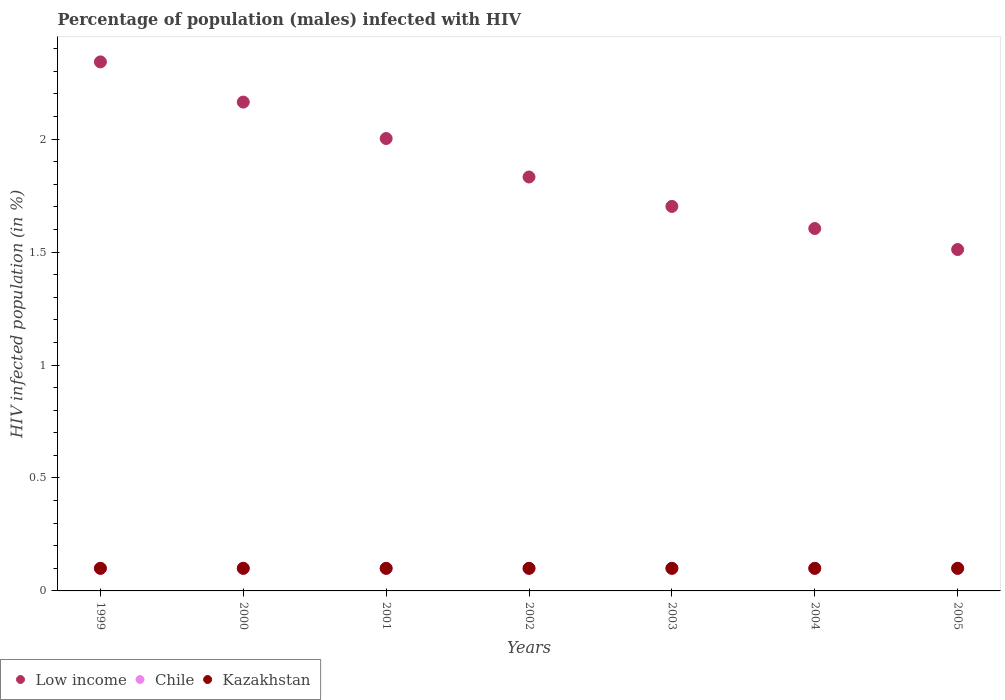How many different coloured dotlines are there?
Keep it short and to the point. 3. Is the number of dotlines equal to the number of legend labels?
Your answer should be very brief. Yes. Across all years, what is the maximum percentage of HIV infected male population in Chile?
Your answer should be compact. 0.1. Across all years, what is the minimum percentage of HIV infected male population in Low income?
Provide a short and direct response. 1.51. What is the total percentage of HIV infected male population in Chile in the graph?
Keep it short and to the point. 0.7. What is the difference between the percentage of HIV infected male population in Kazakhstan in 1999 and that in 2004?
Keep it short and to the point. 0. What is the difference between the percentage of HIV infected male population in Low income in 2005 and the percentage of HIV infected male population in Chile in 2000?
Keep it short and to the point. 1.41. What is the average percentage of HIV infected male population in Low income per year?
Offer a very short reply. 1.88. In the year 2003, what is the difference between the percentage of HIV infected male population in Chile and percentage of HIV infected male population in Kazakhstan?
Ensure brevity in your answer.  0. In how many years, is the percentage of HIV infected male population in Low income greater than 2.2 %?
Give a very brief answer. 1. What is the difference between the highest and the lowest percentage of HIV infected male population in Low income?
Provide a short and direct response. 0.83. In how many years, is the percentage of HIV infected male population in Kazakhstan greater than the average percentage of HIV infected male population in Kazakhstan taken over all years?
Make the answer very short. 7. Is the percentage of HIV infected male population in Chile strictly greater than the percentage of HIV infected male population in Low income over the years?
Offer a very short reply. No. How many dotlines are there?
Make the answer very short. 3. What is the difference between two consecutive major ticks on the Y-axis?
Ensure brevity in your answer.  0.5. Are the values on the major ticks of Y-axis written in scientific E-notation?
Offer a terse response. No. Does the graph contain any zero values?
Ensure brevity in your answer.  No. Does the graph contain grids?
Provide a succinct answer. No. Where does the legend appear in the graph?
Keep it short and to the point. Bottom left. What is the title of the graph?
Ensure brevity in your answer.  Percentage of population (males) infected with HIV. What is the label or title of the Y-axis?
Provide a short and direct response. HIV infected population (in %). What is the HIV infected population (in %) of Low income in 1999?
Offer a very short reply. 2.34. What is the HIV infected population (in %) in Low income in 2000?
Make the answer very short. 2.16. What is the HIV infected population (in %) in Chile in 2000?
Provide a succinct answer. 0.1. What is the HIV infected population (in %) of Low income in 2001?
Keep it short and to the point. 2. What is the HIV infected population (in %) of Low income in 2002?
Ensure brevity in your answer.  1.83. What is the HIV infected population (in %) in Low income in 2003?
Offer a terse response. 1.7. What is the HIV infected population (in %) of Chile in 2003?
Give a very brief answer. 0.1. What is the HIV infected population (in %) in Low income in 2004?
Your answer should be compact. 1.6. What is the HIV infected population (in %) of Kazakhstan in 2004?
Offer a very short reply. 0.1. What is the HIV infected population (in %) of Low income in 2005?
Keep it short and to the point. 1.51. What is the HIV infected population (in %) of Kazakhstan in 2005?
Give a very brief answer. 0.1. Across all years, what is the maximum HIV infected population (in %) in Low income?
Ensure brevity in your answer.  2.34. Across all years, what is the maximum HIV infected population (in %) in Chile?
Give a very brief answer. 0.1. Across all years, what is the minimum HIV infected population (in %) in Low income?
Provide a succinct answer. 1.51. Across all years, what is the minimum HIV infected population (in %) in Chile?
Offer a very short reply. 0.1. What is the total HIV infected population (in %) of Low income in the graph?
Provide a short and direct response. 13.16. What is the total HIV infected population (in %) in Kazakhstan in the graph?
Your answer should be very brief. 0.7. What is the difference between the HIV infected population (in %) of Low income in 1999 and that in 2000?
Your response must be concise. 0.18. What is the difference between the HIV infected population (in %) of Kazakhstan in 1999 and that in 2000?
Make the answer very short. 0. What is the difference between the HIV infected population (in %) in Low income in 1999 and that in 2001?
Offer a terse response. 0.34. What is the difference between the HIV infected population (in %) of Chile in 1999 and that in 2001?
Give a very brief answer. 0. What is the difference between the HIV infected population (in %) in Kazakhstan in 1999 and that in 2001?
Offer a very short reply. 0. What is the difference between the HIV infected population (in %) in Low income in 1999 and that in 2002?
Provide a short and direct response. 0.51. What is the difference between the HIV infected population (in %) in Low income in 1999 and that in 2003?
Provide a succinct answer. 0.64. What is the difference between the HIV infected population (in %) in Kazakhstan in 1999 and that in 2003?
Offer a very short reply. 0. What is the difference between the HIV infected population (in %) of Low income in 1999 and that in 2004?
Offer a very short reply. 0.74. What is the difference between the HIV infected population (in %) of Chile in 1999 and that in 2004?
Provide a succinct answer. 0. What is the difference between the HIV infected population (in %) in Kazakhstan in 1999 and that in 2004?
Ensure brevity in your answer.  0. What is the difference between the HIV infected population (in %) of Low income in 1999 and that in 2005?
Give a very brief answer. 0.83. What is the difference between the HIV infected population (in %) in Chile in 1999 and that in 2005?
Your answer should be very brief. 0. What is the difference between the HIV infected population (in %) of Kazakhstan in 1999 and that in 2005?
Keep it short and to the point. 0. What is the difference between the HIV infected population (in %) in Low income in 2000 and that in 2001?
Offer a terse response. 0.16. What is the difference between the HIV infected population (in %) in Chile in 2000 and that in 2001?
Make the answer very short. 0. What is the difference between the HIV infected population (in %) in Low income in 2000 and that in 2002?
Provide a short and direct response. 0.33. What is the difference between the HIV infected population (in %) in Chile in 2000 and that in 2002?
Provide a succinct answer. 0. What is the difference between the HIV infected population (in %) of Low income in 2000 and that in 2003?
Provide a short and direct response. 0.46. What is the difference between the HIV infected population (in %) of Chile in 2000 and that in 2003?
Offer a terse response. 0. What is the difference between the HIV infected population (in %) of Kazakhstan in 2000 and that in 2003?
Provide a short and direct response. 0. What is the difference between the HIV infected population (in %) of Low income in 2000 and that in 2004?
Ensure brevity in your answer.  0.56. What is the difference between the HIV infected population (in %) of Chile in 2000 and that in 2004?
Make the answer very short. 0. What is the difference between the HIV infected population (in %) of Kazakhstan in 2000 and that in 2004?
Offer a terse response. 0. What is the difference between the HIV infected population (in %) in Low income in 2000 and that in 2005?
Your response must be concise. 0.65. What is the difference between the HIV infected population (in %) in Kazakhstan in 2000 and that in 2005?
Your answer should be compact. 0. What is the difference between the HIV infected population (in %) of Low income in 2001 and that in 2002?
Make the answer very short. 0.17. What is the difference between the HIV infected population (in %) of Chile in 2001 and that in 2002?
Provide a succinct answer. 0. What is the difference between the HIV infected population (in %) of Kazakhstan in 2001 and that in 2002?
Provide a short and direct response. 0. What is the difference between the HIV infected population (in %) of Low income in 2001 and that in 2003?
Offer a terse response. 0.3. What is the difference between the HIV infected population (in %) in Kazakhstan in 2001 and that in 2003?
Offer a very short reply. 0. What is the difference between the HIV infected population (in %) in Low income in 2001 and that in 2004?
Give a very brief answer. 0.4. What is the difference between the HIV infected population (in %) of Chile in 2001 and that in 2004?
Provide a succinct answer. 0. What is the difference between the HIV infected population (in %) in Kazakhstan in 2001 and that in 2004?
Your answer should be very brief. 0. What is the difference between the HIV infected population (in %) in Low income in 2001 and that in 2005?
Give a very brief answer. 0.49. What is the difference between the HIV infected population (in %) in Low income in 2002 and that in 2003?
Make the answer very short. 0.13. What is the difference between the HIV infected population (in %) in Kazakhstan in 2002 and that in 2003?
Give a very brief answer. 0. What is the difference between the HIV infected population (in %) of Low income in 2002 and that in 2004?
Keep it short and to the point. 0.23. What is the difference between the HIV infected population (in %) of Chile in 2002 and that in 2004?
Your answer should be very brief. 0. What is the difference between the HIV infected population (in %) in Low income in 2002 and that in 2005?
Provide a short and direct response. 0.32. What is the difference between the HIV infected population (in %) in Chile in 2002 and that in 2005?
Your response must be concise. 0. What is the difference between the HIV infected population (in %) in Kazakhstan in 2002 and that in 2005?
Keep it short and to the point. 0. What is the difference between the HIV infected population (in %) in Low income in 2003 and that in 2004?
Give a very brief answer. 0.1. What is the difference between the HIV infected population (in %) of Low income in 2003 and that in 2005?
Your response must be concise. 0.19. What is the difference between the HIV infected population (in %) in Chile in 2003 and that in 2005?
Make the answer very short. 0. What is the difference between the HIV infected population (in %) in Low income in 2004 and that in 2005?
Give a very brief answer. 0.09. What is the difference between the HIV infected population (in %) in Kazakhstan in 2004 and that in 2005?
Ensure brevity in your answer.  0. What is the difference between the HIV infected population (in %) in Low income in 1999 and the HIV infected population (in %) in Chile in 2000?
Your answer should be very brief. 2.24. What is the difference between the HIV infected population (in %) in Low income in 1999 and the HIV infected population (in %) in Kazakhstan in 2000?
Give a very brief answer. 2.24. What is the difference between the HIV infected population (in %) in Low income in 1999 and the HIV infected population (in %) in Chile in 2001?
Your answer should be very brief. 2.24. What is the difference between the HIV infected population (in %) of Low income in 1999 and the HIV infected population (in %) of Kazakhstan in 2001?
Your response must be concise. 2.24. What is the difference between the HIV infected population (in %) in Low income in 1999 and the HIV infected population (in %) in Chile in 2002?
Keep it short and to the point. 2.24. What is the difference between the HIV infected population (in %) of Low income in 1999 and the HIV infected population (in %) of Kazakhstan in 2002?
Give a very brief answer. 2.24. What is the difference between the HIV infected population (in %) of Low income in 1999 and the HIV infected population (in %) of Chile in 2003?
Your answer should be compact. 2.24. What is the difference between the HIV infected population (in %) in Low income in 1999 and the HIV infected population (in %) in Kazakhstan in 2003?
Offer a terse response. 2.24. What is the difference between the HIV infected population (in %) in Chile in 1999 and the HIV infected population (in %) in Kazakhstan in 2003?
Your answer should be very brief. 0. What is the difference between the HIV infected population (in %) in Low income in 1999 and the HIV infected population (in %) in Chile in 2004?
Offer a very short reply. 2.24. What is the difference between the HIV infected population (in %) in Low income in 1999 and the HIV infected population (in %) in Kazakhstan in 2004?
Offer a very short reply. 2.24. What is the difference between the HIV infected population (in %) of Low income in 1999 and the HIV infected population (in %) of Chile in 2005?
Ensure brevity in your answer.  2.24. What is the difference between the HIV infected population (in %) in Low income in 1999 and the HIV infected population (in %) in Kazakhstan in 2005?
Keep it short and to the point. 2.24. What is the difference between the HIV infected population (in %) of Chile in 1999 and the HIV infected population (in %) of Kazakhstan in 2005?
Keep it short and to the point. 0. What is the difference between the HIV infected population (in %) in Low income in 2000 and the HIV infected population (in %) in Chile in 2001?
Your response must be concise. 2.06. What is the difference between the HIV infected population (in %) in Low income in 2000 and the HIV infected population (in %) in Kazakhstan in 2001?
Ensure brevity in your answer.  2.06. What is the difference between the HIV infected population (in %) in Low income in 2000 and the HIV infected population (in %) in Chile in 2002?
Give a very brief answer. 2.06. What is the difference between the HIV infected population (in %) of Low income in 2000 and the HIV infected population (in %) of Kazakhstan in 2002?
Keep it short and to the point. 2.06. What is the difference between the HIV infected population (in %) in Low income in 2000 and the HIV infected population (in %) in Chile in 2003?
Your answer should be very brief. 2.06. What is the difference between the HIV infected population (in %) of Low income in 2000 and the HIV infected population (in %) of Kazakhstan in 2003?
Provide a succinct answer. 2.06. What is the difference between the HIV infected population (in %) in Low income in 2000 and the HIV infected population (in %) in Chile in 2004?
Make the answer very short. 2.06. What is the difference between the HIV infected population (in %) in Low income in 2000 and the HIV infected population (in %) in Kazakhstan in 2004?
Your answer should be compact. 2.06. What is the difference between the HIV infected population (in %) in Low income in 2000 and the HIV infected population (in %) in Chile in 2005?
Your answer should be compact. 2.06. What is the difference between the HIV infected population (in %) of Low income in 2000 and the HIV infected population (in %) of Kazakhstan in 2005?
Give a very brief answer. 2.06. What is the difference between the HIV infected population (in %) of Low income in 2001 and the HIV infected population (in %) of Chile in 2002?
Provide a short and direct response. 1.9. What is the difference between the HIV infected population (in %) of Low income in 2001 and the HIV infected population (in %) of Kazakhstan in 2002?
Make the answer very short. 1.9. What is the difference between the HIV infected population (in %) of Chile in 2001 and the HIV infected population (in %) of Kazakhstan in 2002?
Make the answer very short. 0. What is the difference between the HIV infected population (in %) of Low income in 2001 and the HIV infected population (in %) of Chile in 2003?
Give a very brief answer. 1.9. What is the difference between the HIV infected population (in %) of Low income in 2001 and the HIV infected population (in %) of Kazakhstan in 2003?
Your answer should be very brief. 1.9. What is the difference between the HIV infected population (in %) of Chile in 2001 and the HIV infected population (in %) of Kazakhstan in 2003?
Your answer should be compact. 0. What is the difference between the HIV infected population (in %) of Low income in 2001 and the HIV infected population (in %) of Chile in 2004?
Keep it short and to the point. 1.9. What is the difference between the HIV infected population (in %) in Low income in 2001 and the HIV infected population (in %) in Kazakhstan in 2004?
Your response must be concise. 1.9. What is the difference between the HIV infected population (in %) in Chile in 2001 and the HIV infected population (in %) in Kazakhstan in 2004?
Provide a short and direct response. 0. What is the difference between the HIV infected population (in %) in Low income in 2001 and the HIV infected population (in %) in Chile in 2005?
Provide a succinct answer. 1.9. What is the difference between the HIV infected population (in %) of Low income in 2001 and the HIV infected population (in %) of Kazakhstan in 2005?
Provide a short and direct response. 1.9. What is the difference between the HIV infected population (in %) of Chile in 2001 and the HIV infected population (in %) of Kazakhstan in 2005?
Make the answer very short. 0. What is the difference between the HIV infected population (in %) of Low income in 2002 and the HIV infected population (in %) of Chile in 2003?
Give a very brief answer. 1.73. What is the difference between the HIV infected population (in %) of Low income in 2002 and the HIV infected population (in %) of Kazakhstan in 2003?
Provide a short and direct response. 1.73. What is the difference between the HIV infected population (in %) of Chile in 2002 and the HIV infected population (in %) of Kazakhstan in 2003?
Make the answer very short. 0. What is the difference between the HIV infected population (in %) in Low income in 2002 and the HIV infected population (in %) in Chile in 2004?
Offer a terse response. 1.73. What is the difference between the HIV infected population (in %) in Low income in 2002 and the HIV infected population (in %) in Kazakhstan in 2004?
Provide a short and direct response. 1.73. What is the difference between the HIV infected population (in %) of Low income in 2002 and the HIV infected population (in %) of Chile in 2005?
Provide a succinct answer. 1.73. What is the difference between the HIV infected population (in %) of Low income in 2002 and the HIV infected population (in %) of Kazakhstan in 2005?
Provide a short and direct response. 1.73. What is the difference between the HIV infected population (in %) of Chile in 2002 and the HIV infected population (in %) of Kazakhstan in 2005?
Your response must be concise. 0. What is the difference between the HIV infected population (in %) in Low income in 2003 and the HIV infected population (in %) in Chile in 2004?
Make the answer very short. 1.6. What is the difference between the HIV infected population (in %) of Low income in 2003 and the HIV infected population (in %) of Kazakhstan in 2004?
Your answer should be compact. 1.6. What is the difference between the HIV infected population (in %) in Low income in 2003 and the HIV infected population (in %) in Chile in 2005?
Your answer should be very brief. 1.6. What is the difference between the HIV infected population (in %) in Low income in 2003 and the HIV infected population (in %) in Kazakhstan in 2005?
Provide a succinct answer. 1.6. What is the difference between the HIV infected population (in %) of Chile in 2003 and the HIV infected population (in %) of Kazakhstan in 2005?
Offer a very short reply. 0. What is the difference between the HIV infected population (in %) in Low income in 2004 and the HIV infected population (in %) in Chile in 2005?
Keep it short and to the point. 1.5. What is the difference between the HIV infected population (in %) of Low income in 2004 and the HIV infected population (in %) of Kazakhstan in 2005?
Your answer should be very brief. 1.5. What is the difference between the HIV infected population (in %) in Chile in 2004 and the HIV infected population (in %) in Kazakhstan in 2005?
Offer a very short reply. 0. What is the average HIV infected population (in %) of Low income per year?
Keep it short and to the point. 1.88. In the year 1999, what is the difference between the HIV infected population (in %) in Low income and HIV infected population (in %) in Chile?
Your answer should be compact. 2.24. In the year 1999, what is the difference between the HIV infected population (in %) of Low income and HIV infected population (in %) of Kazakhstan?
Your response must be concise. 2.24. In the year 2000, what is the difference between the HIV infected population (in %) in Low income and HIV infected population (in %) in Chile?
Ensure brevity in your answer.  2.06. In the year 2000, what is the difference between the HIV infected population (in %) of Low income and HIV infected population (in %) of Kazakhstan?
Make the answer very short. 2.06. In the year 2000, what is the difference between the HIV infected population (in %) in Chile and HIV infected population (in %) in Kazakhstan?
Your response must be concise. 0. In the year 2001, what is the difference between the HIV infected population (in %) of Low income and HIV infected population (in %) of Chile?
Your response must be concise. 1.9. In the year 2001, what is the difference between the HIV infected population (in %) of Low income and HIV infected population (in %) of Kazakhstan?
Make the answer very short. 1.9. In the year 2001, what is the difference between the HIV infected population (in %) in Chile and HIV infected population (in %) in Kazakhstan?
Offer a terse response. 0. In the year 2002, what is the difference between the HIV infected population (in %) of Low income and HIV infected population (in %) of Chile?
Offer a terse response. 1.73. In the year 2002, what is the difference between the HIV infected population (in %) of Low income and HIV infected population (in %) of Kazakhstan?
Offer a very short reply. 1.73. In the year 2002, what is the difference between the HIV infected population (in %) in Chile and HIV infected population (in %) in Kazakhstan?
Offer a terse response. 0. In the year 2003, what is the difference between the HIV infected population (in %) of Low income and HIV infected population (in %) of Chile?
Ensure brevity in your answer.  1.6. In the year 2003, what is the difference between the HIV infected population (in %) in Low income and HIV infected population (in %) in Kazakhstan?
Keep it short and to the point. 1.6. In the year 2003, what is the difference between the HIV infected population (in %) in Chile and HIV infected population (in %) in Kazakhstan?
Give a very brief answer. 0. In the year 2004, what is the difference between the HIV infected population (in %) of Low income and HIV infected population (in %) of Chile?
Provide a succinct answer. 1.5. In the year 2004, what is the difference between the HIV infected population (in %) of Low income and HIV infected population (in %) of Kazakhstan?
Give a very brief answer. 1.5. In the year 2005, what is the difference between the HIV infected population (in %) of Low income and HIV infected population (in %) of Chile?
Ensure brevity in your answer.  1.41. In the year 2005, what is the difference between the HIV infected population (in %) of Low income and HIV infected population (in %) of Kazakhstan?
Offer a terse response. 1.41. In the year 2005, what is the difference between the HIV infected population (in %) of Chile and HIV infected population (in %) of Kazakhstan?
Your answer should be very brief. 0. What is the ratio of the HIV infected population (in %) of Low income in 1999 to that in 2000?
Provide a short and direct response. 1.08. What is the ratio of the HIV infected population (in %) of Low income in 1999 to that in 2001?
Your response must be concise. 1.17. What is the ratio of the HIV infected population (in %) of Chile in 1999 to that in 2001?
Provide a succinct answer. 1. What is the ratio of the HIV infected population (in %) in Kazakhstan in 1999 to that in 2001?
Keep it short and to the point. 1. What is the ratio of the HIV infected population (in %) of Low income in 1999 to that in 2002?
Ensure brevity in your answer.  1.28. What is the ratio of the HIV infected population (in %) of Chile in 1999 to that in 2002?
Offer a very short reply. 1. What is the ratio of the HIV infected population (in %) of Low income in 1999 to that in 2003?
Your answer should be compact. 1.38. What is the ratio of the HIV infected population (in %) of Low income in 1999 to that in 2004?
Give a very brief answer. 1.46. What is the ratio of the HIV infected population (in %) in Kazakhstan in 1999 to that in 2004?
Make the answer very short. 1. What is the ratio of the HIV infected population (in %) of Low income in 1999 to that in 2005?
Ensure brevity in your answer.  1.55. What is the ratio of the HIV infected population (in %) of Chile in 1999 to that in 2005?
Provide a succinct answer. 1. What is the ratio of the HIV infected population (in %) in Low income in 2000 to that in 2001?
Keep it short and to the point. 1.08. What is the ratio of the HIV infected population (in %) of Chile in 2000 to that in 2001?
Give a very brief answer. 1. What is the ratio of the HIV infected population (in %) in Low income in 2000 to that in 2002?
Give a very brief answer. 1.18. What is the ratio of the HIV infected population (in %) in Kazakhstan in 2000 to that in 2002?
Provide a succinct answer. 1. What is the ratio of the HIV infected population (in %) of Low income in 2000 to that in 2003?
Your answer should be very brief. 1.27. What is the ratio of the HIV infected population (in %) in Chile in 2000 to that in 2003?
Give a very brief answer. 1. What is the ratio of the HIV infected population (in %) in Kazakhstan in 2000 to that in 2003?
Ensure brevity in your answer.  1. What is the ratio of the HIV infected population (in %) in Low income in 2000 to that in 2004?
Make the answer very short. 1.35. What is the ratio of the HIV infected population (in %) in Chile in 2000 to that in 2004?
Your answer should be compact. 1. What is the ratio of the HIV infected population (in %) in Kazakhstan in 2000 to that in 2004?
Provide a short and direct response. 1. What is the ratio of the HIV infected population (in %) in Low income in 2000 to that in 2005?
Your answer should be very brief. 1.43. What is the ratio of the HIV infected population (in %) of Chile in 2000 to that in 2005?
Offer a terse response. 1. What is the ratio of the HIV infected population (in %) of Low income in 2001 to that in 2002?
Provide a succinct answer. 1.09. What is the ratio of the HIV infected population (in %) in Kazakhstan in 2001 to that in 2002?
Your answer should be compact. 1. What is the ratio of the HIV infected population (in %) in Low income in 2001 to that in 2003?
Your response must be concise. 1.18. What is the ratio of the HIV infected population (in %) of Low income in 2001 to that in 2004?
Offer a terse response. 1.25. What is the ratio of the HIV infected population (in %) in Chile in 2001 to that in 2004?
Make the answer very short. 1. What is the ratio of the HIV infected population (in %) of Kazakhstan in 2001 to that in 2004?
Your response must be concise. 1. What is the ratio of the HIV infected population (in %) in Low income in 2001 to that in 2005?
Give a very brief answer. 1.33. What is the ratio of the HIV infected population (in %) of Chile in 2001 to that in 2005?
Offer a terse response. 1. What is the ratio of the HIV infected population (in %) of Low income in 2002 to that in 2003?
Provide a succinct answer. 1.08. What is the ratio of the HIV infected population (in %) of Kazakhstan in 2002 to that in 2003?
Keep it short and to the point. 1. What is the ratio of the HIV infected population (in %) in Low income in 2002 to that in 2004?
Offer a terse response. 1.14. What is the ratio of the HIV infected population (in %) of Low income in 2002 to that in 2005?
Provide a short and direct response. 1.21. What is the ratio of the HIV infected population (in %) of Kazakhstan in 2002 to that in 2005?
Offer a terse response. 1. What is the ratio of the HIV infected population (in %) of Low income in 2003 to that in 2004?
Your answer should be compact. 1.06. What is the ratio of the HIV infected population (in %) of Kazakhstan in 2003 to that in 2004?
Your answer should be very brief. 1. What is the ratio of the HIV infected population (in %) of Low income in 2003 to that in 2005?
Offer a terse response. 1.13. What is the ratio of the HIV infected population (in %) of Chile in 2003 to that in 2005?
Offer a very short reply. 1. What is the ratio of the HIV infected population (in %) in Low income in 2004 to that in 2005?
Ensure brevity in your answer.  1.06. What is the ratio of the HIV infected population (in %) in Kazakhstan in 2004 to that in 2005?
Your response must be concise. 1. What is the difference between the highest and the second highest HIV infected population (in %) in Low income?
Provide a succinct answer. 0.18. What is the difference between the highest and the second highest HIV infected population (in %) of Kazakhstan?
Your response must be concise. 0. What is the difference between the highest and the lowest HIV infected population (in %) of Low income?
Your answer should be compact. 0.83. What is the difference between the highest and the lowest HIV infected population (in %) of Chile?
Your response must be concise. 0. 